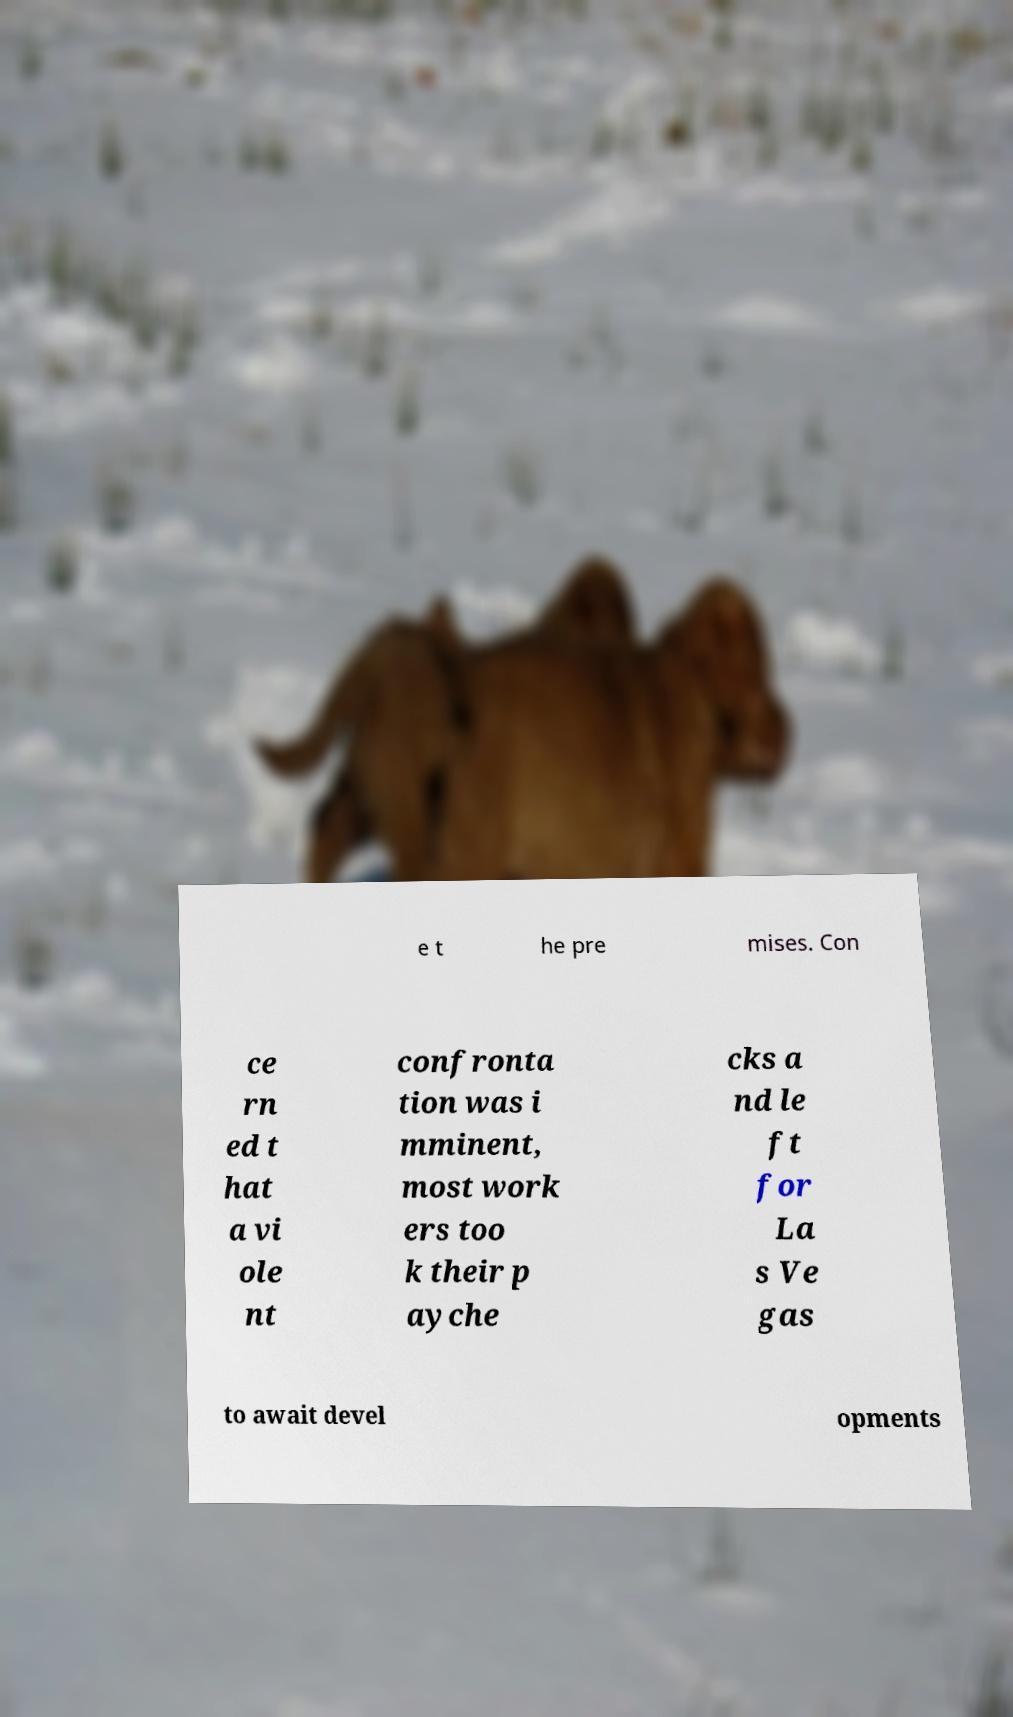What messages or text are displayed in this image? I need them in a readable, typed format. e t he pre mises. Con ce rn ed t hat a vi ole nt confronta tion was i mminent, most work ers too k their p ayche cks a nd le ft for La s Ve gas to await devel opments 